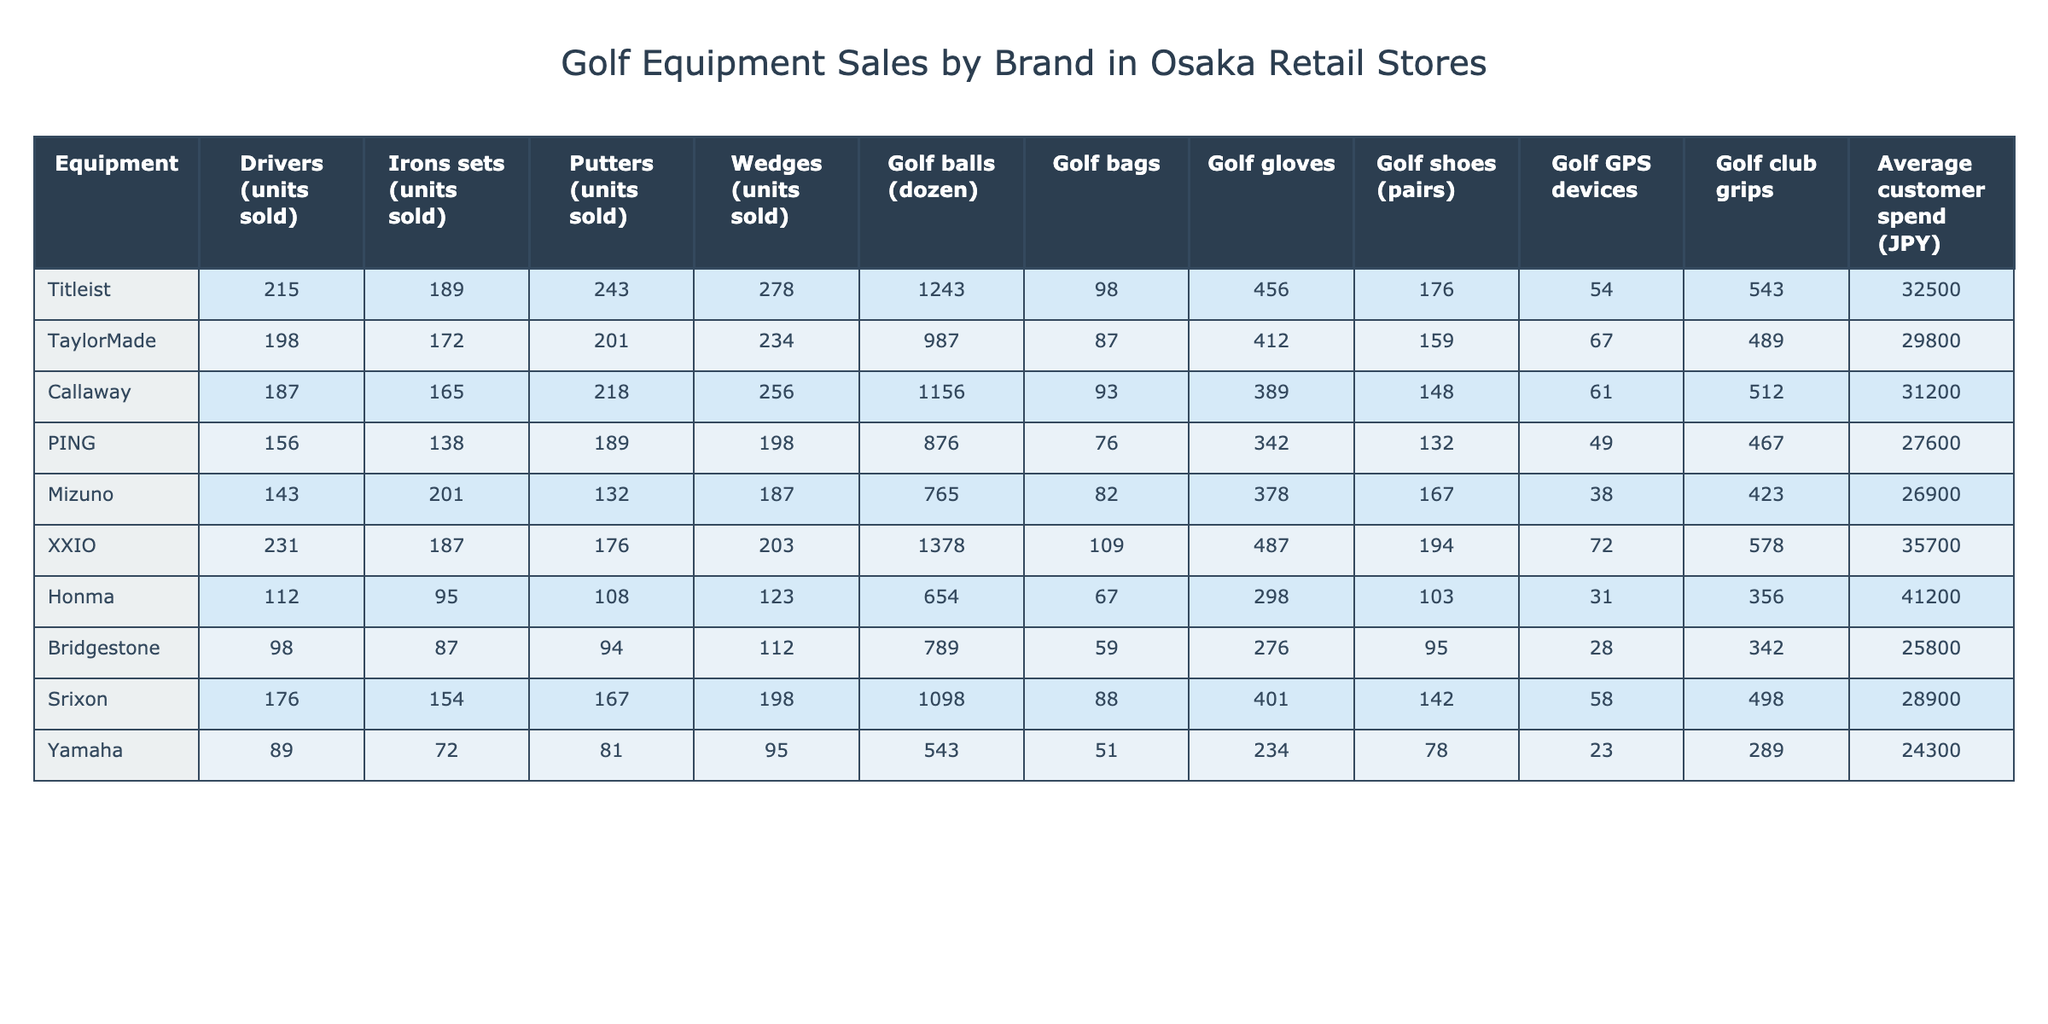What brand sold the most drivers? By looking at the "Drivers (units sold)" row, Titleist has the highest sales with 215 units sold, which is more than any other brand.
Answer: Titleist Which brand has the lowest sales of golf bags? In the "Golf bags" row, the brand with the lowest sales is Yamaha, with only 51 units sold, as indicated in that column.
Answer: Yamaha What is the total number of golf gloves sold by all brands? To find the total, I will sum all listed values in the "Golf gloves" row: (456 + 412 + 389 + 342 + 378 + 487 + 298 + 276 + 401 + 234) = 3,473.
Answer: 3473 Which brand has the highest average customer spend? By checking the "Average customer spend (JPY)" row, I see that Honma has the highest average spend of 41,200 JPY, which is higher than all other brands listed.
Answer: Honma What is the difference in golf ball sales between XXIO and Mizuno? I subtract the sales of Mizuno (765) from XXIO (1,378): 1,378 - 765 = 613, so there is a difference of 613 dozen golf balls sold.
Answer: 613 What percentage of the golf shoes sold were by PING compared to the total sold? First, I will find the total number of golf shoes sold: (176 + 159 + 148 + 132 + 167 + 194 + 103 + 95 + 142 + 78) = 1,392. PING sold 132 pairs. To find the percentage: (132/1,392) * 100 ≈ 9.48%, hence PING's sales represent about 9.48% of the total.
Answer: 9.48% Is Callaway the only brand that sold more than 200 golf balls? Upon checking the "Golf balls (dozen)" row, I can see that both Titleist and Callaway sold more than 1,000 dozen golf balls and Callaway's sales alone do not make it the only brand over 200 dozen golf balls.
Answer: No Which brand had the highest sales of putters and how many units were sold? Looking at the "Putters (units sold)" row, I see that Titleist leads with 243 units sold, making this the highest in that category.
Answer: 243 Which equipment category did Bridgestone sell the least units? By checking the table, I find Bridgestone sold the least units in the "Golf bags" category, where only 59 units were sold, compared to all other equipment categories.
Answer: Golf bags What is the average number of drivers sold across all brands? I calculate the average drivers sold by adding up all units: (215 + 198 + 187 + 156 + 143 + 231 + 112 + 98 + 176 + 89) = 1,605; dividing this by the number of brands (10): 1,605 / 10 = 160.5.
Answer: 160.5 Who sells more golf clubs, Callaway or TaylorMade? Observing the "Irons sets (units sold)" row, TaylorMade has sold 172 units while Callaway sold 165 units, proving that TaylorMade sells more.
Answer: TaylorMade 